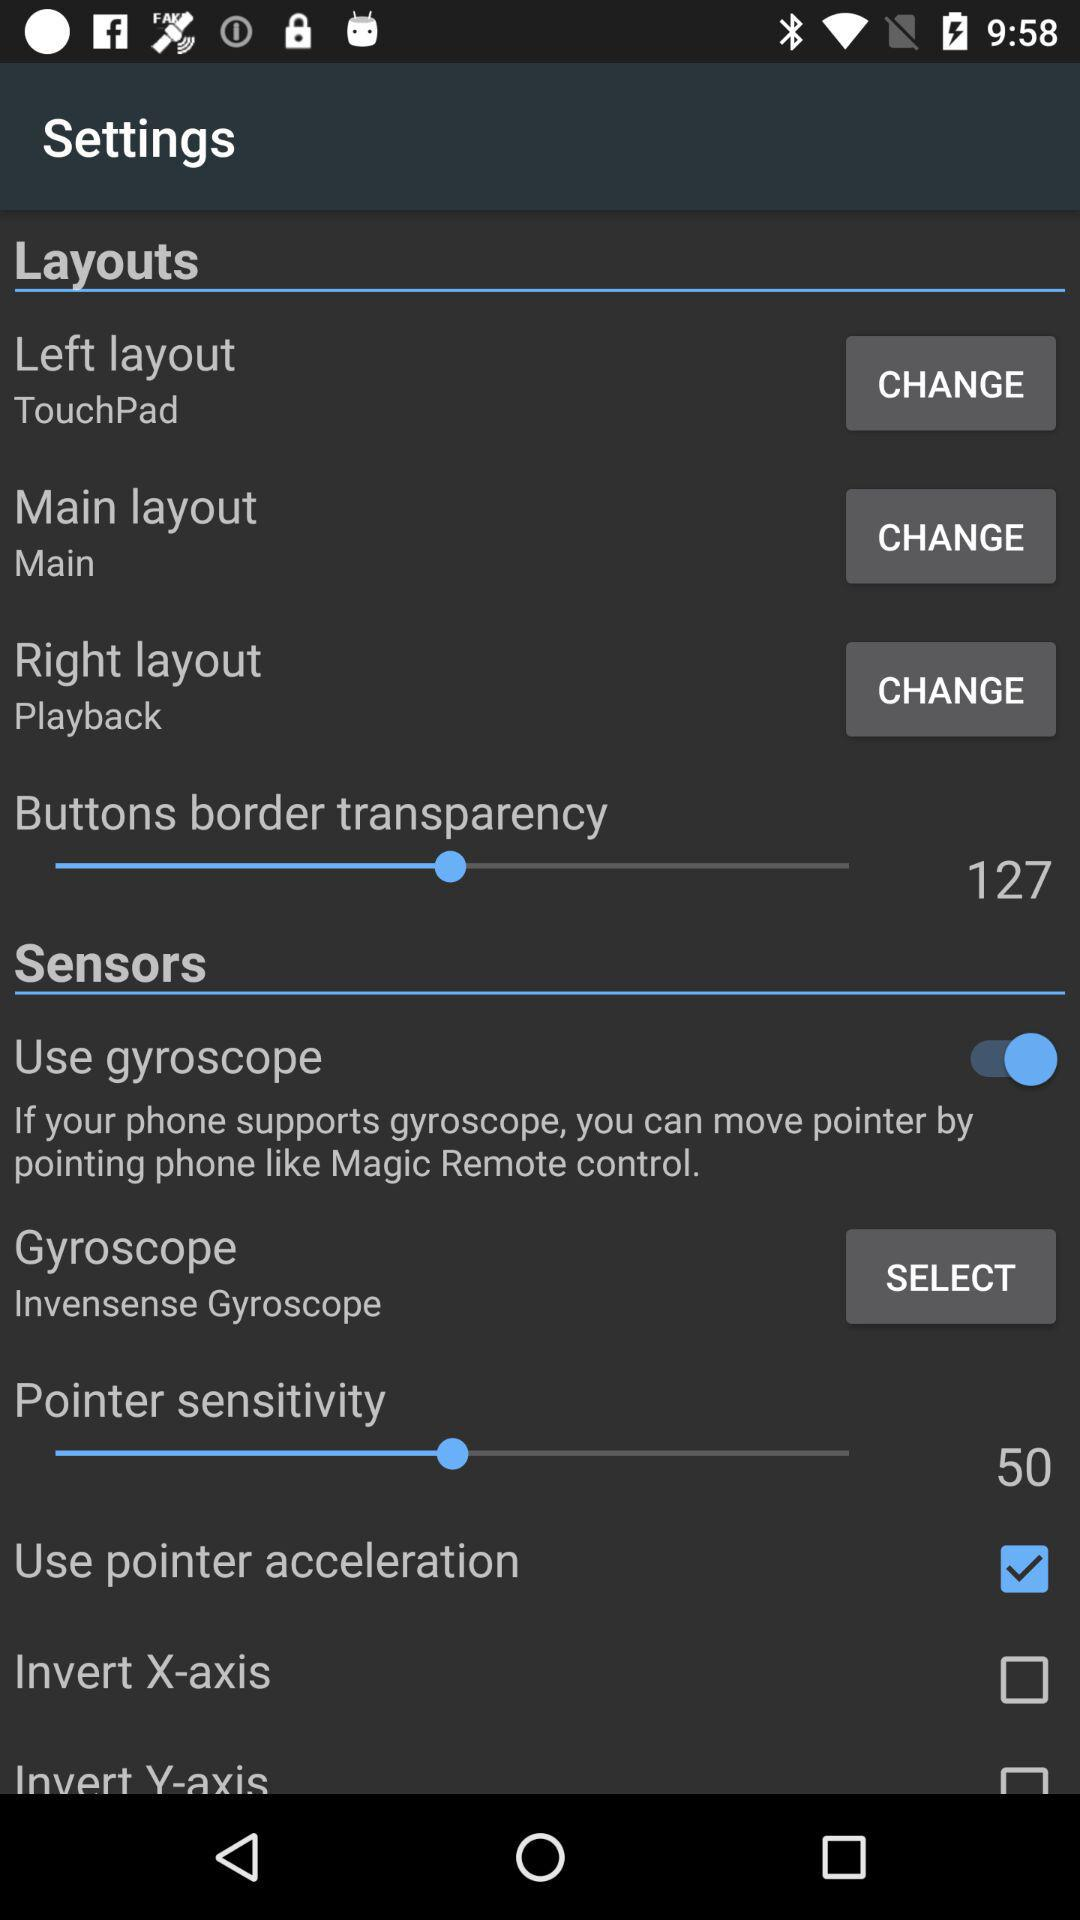What is the status of the "Use gyroscope"? The status is "on". 